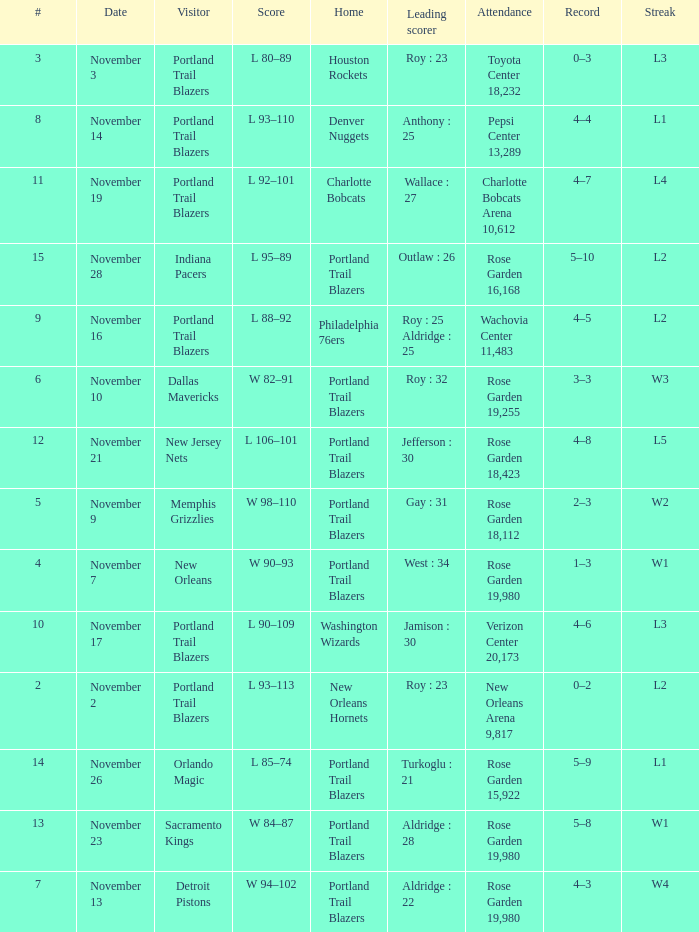 what's the attendance where score is l 92–101 Charlotte Bobcats Arena 10,612. 